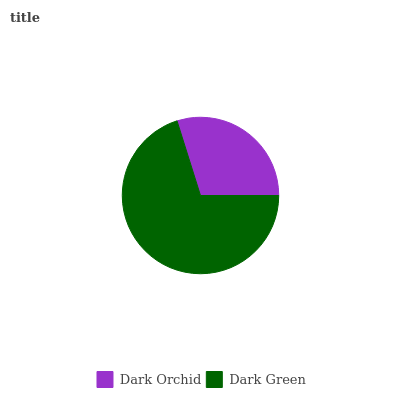Is Dark Orchid the minimum?
Answer yes or no. Yes. Is Dark Green the maximum?
Answer yes or no. Yes. Is Dark Green the minimum?
Answer yes or no. No. Is Dark Green greater than Dark Orchid?
Answer yes or no. Yes. Is Dark Orchid less than Dark Green?
Answer yes or no. Yes. Is Dark Orchid greater than Dark Green?
Answer yes or no. No. Is Dark Green less than Dark Orchid?
Answer yes or no. No. Is Dark Green the high median?
Answer yes or no. Yes. Is Dark Orchid the low median?
Answer yes or no. Yes. Is Dark Orchid the high median?
Answer yes or no. No. Is Dark Green the low median?
Answer yes or no. No. 